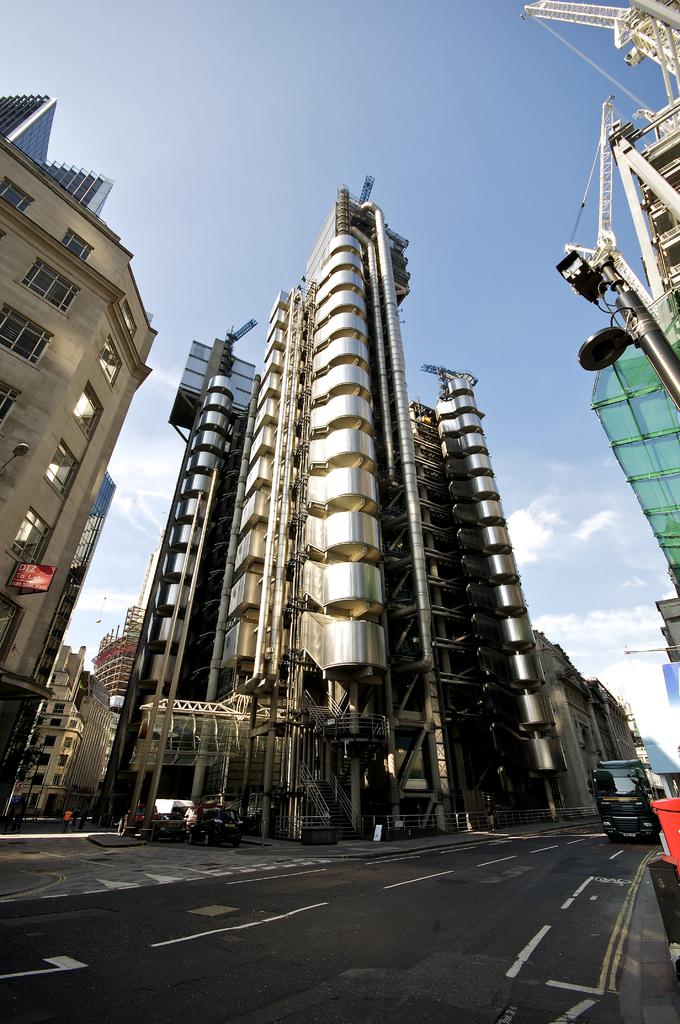What type of structures can be seen in the image? There are buildings in the image. What else is present in the image besides buildings? Motor vehicles and iron grills are visible in the image. What can be seen in the sky in the image? The sky is visible in the image, and clouds are present. What type of grass is used to make the quilt in the image? There is no quilt or grass present in the image. 